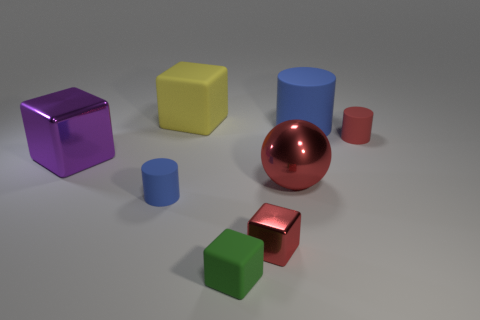What number of small things are either green cubes or blue objects?
Give a very brief answer. 2. Does the metal cube that is behind the small blue cylinder have the same color as the small cylinder that is left of the large cylinder?
Your answer should be very brief. No. What number of other things are the same color as the large shiny ball?
Ensure brevity in your answer.  2. How many red objects are either shiny objects or big rubber cylinders?
Offer a terse response. 2. There is a tiny blue object; is its shape the same as the big metallic object that is on the right side of the large rubber block?
Your answer should be very brief. No. What is the shape of the large blue matte object?
Offer a very short reply. Cylinder. What is the material of the blue cylinder that is the same size as the green matte object?
Keep it short and to the point. Rubber. Is there anything else that has the same size as the purple shiny block?
Offer a very short reply. Yes. What number of objects are tiny red shiny cubes or objects on the left side of the yellow matte object?
Give a very brief answer. 3. What is the size of the purple thing that is made of the same material as the red block?
Provide a succinct answer. Large. 